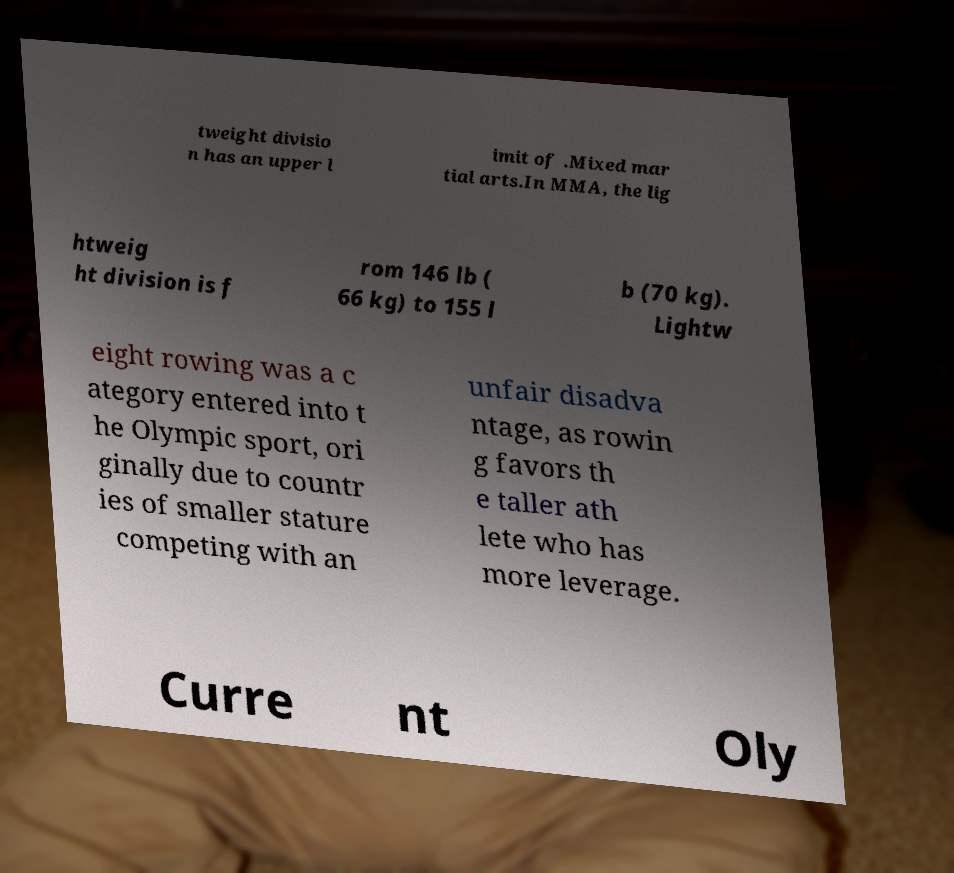Could you assist in decoding the text presented in this image and type it out clearly? tweight divisio n has an upper l imit of .Mixed mar tial arts.In MMA, the lig htweig ht division is f rom 146 lb ( 66 kg) to 155 l b (70 kg). Lightw eight rowing was a c ategory entered into t he Olympic sport, ori ginally due to countr ies of smaller stature competing with an unfair disadva ntage, as rowin g favors th e taller ath lete who has more leverage. Curre nt Oly 